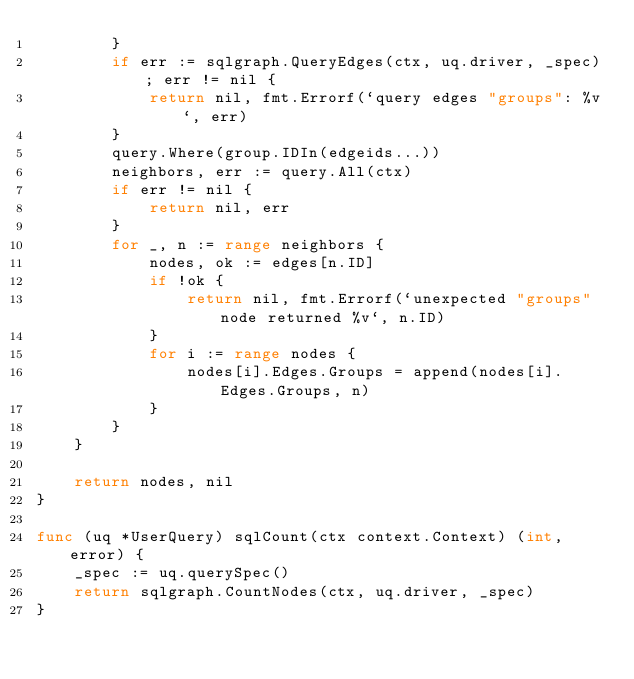<code> <loc_0><loc_0><loc_500><loc_500><_Go_>		}
		if err := sqlgraph.QueryEdges(ctx, uq.driver, _spec); err != nil {
			return nil, fmt.Errorf(`query edges "groups": %v`, err)
		}
		query.Where(group.IDIn(edgeids...))
		neighbors, err := query.All(ctx)
		if err != nil {
			return nil, err
		}
		for _, n := range neighbors {
			nodes, ok := edges[n.ID]
			if !ok {
				return nil, fmt.Errorf(`unexpected "groups" node returned %v`, n.ID)
			}
			for i := range nodes {
				nodes[i].Edges.Groups = append(nodes[i].Edges.Groups, n)
			}
		}
	}

	return nodes, nil
}

func (uq *UserQuery) sqlCount(ctx context.Context) (int, error) {
	_spec := uq.querySpec()
	return sqlgraph.CountNodes(ctx, uq.driver, _spec)
}
</code> 